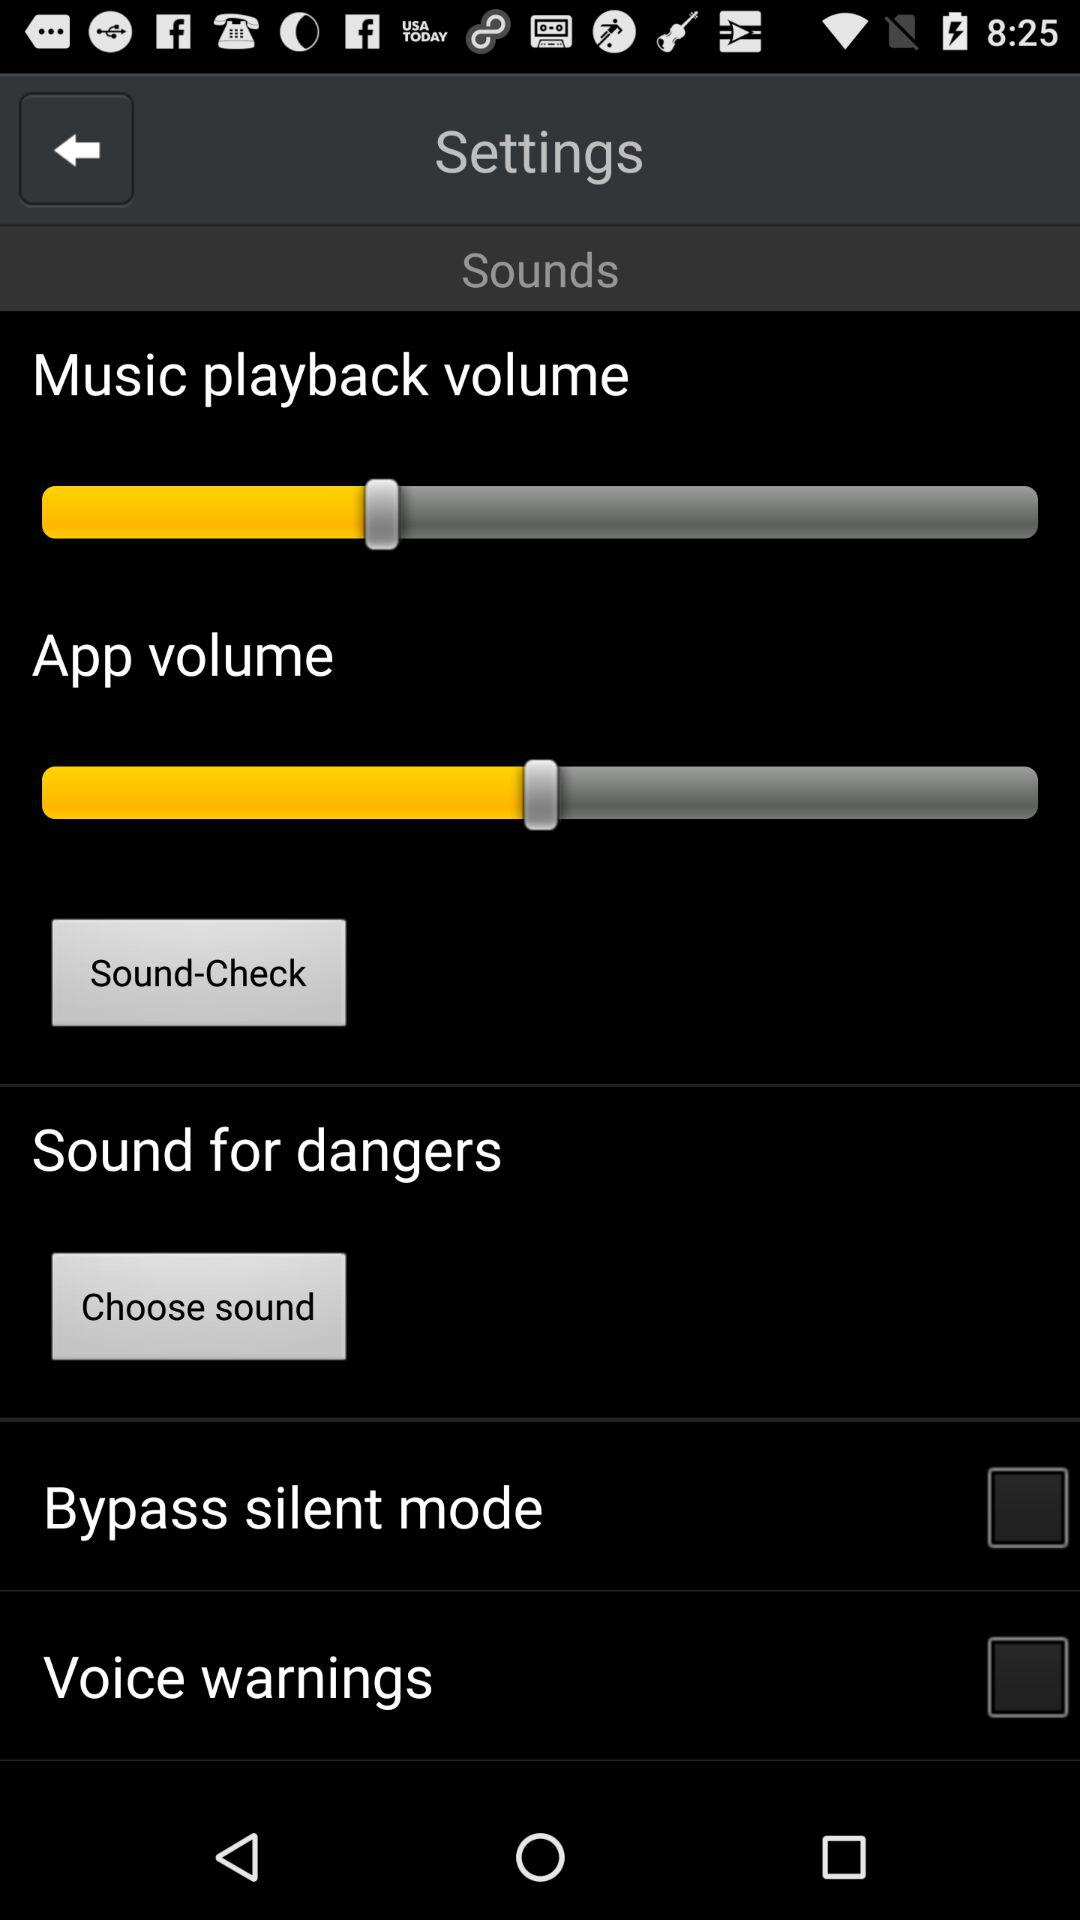How high is the percentage of the music playback volume?
When the provided information is insufficient, respond with <no answer>. <no answer> 